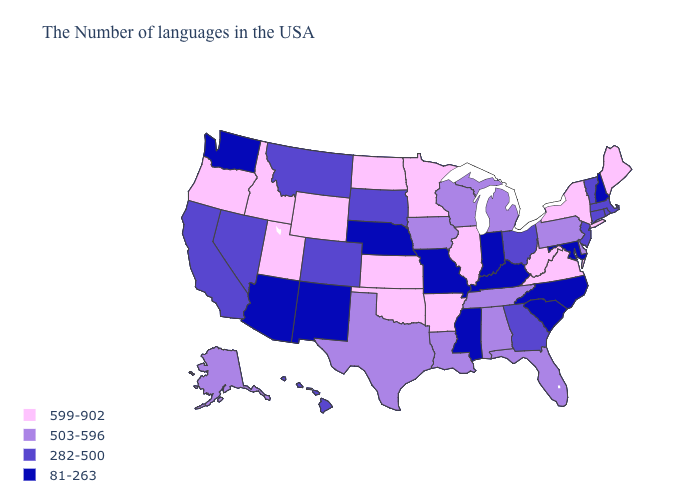Name the states that have a value in the range 503-596?
Give a very brief answer. Delaware, Pennsylvania, Florida, Michigan, Alabama, Tennessee, Wisconsin, Louisiana, Iowa, Texas, Alaska. Does the map have missing data?
Keep it brief. No. Name the states that have a value in the range 503-596?
Keep it brief. Delaware, Pennsylvania, Florida, Michigan, Alabama, Tennessee, Wisconsin, Louisiana, Iowa, Texas, Alaska. Among the states that border Alabama , does Mississippi have the lowest value?
Quick response, please. Yes. What is the value of Montana?
Quick response, please. 282-500. Among the states that border Minnesota , does North Dakota have the highest value?
Keep it brief. Yes. What is the highest value in states that border Vermont?
Concise answer only. 599-902. Which states have the highest value in the USA?
Be succinct. Maine, New York, Virginia, West Virginia, Illinois, Arkansas, Minnesota, Kansas, Oklahoma, North Dakota, Wyoming, Utah, Idaho, Oregon. Among the states that border Delaware , which have the highest value?
Short answer required. Pennsylvania. Name the states that have a value in the range 599-902?
Short answer required. Maine, New York, Virginia, West Virginia, Illinois, Arkansas, Minnesota, Kansas, Oklahoma, North Dakota, Wyoming, Utah, Idaho, Oregon. What is the highest value in the Northeast ?
Short answer required. 599-902. Name the states that have a value in the range 503-596?
Short answer required. Delaware, Pennsylvania, Florida, Michigan, Alabama, Tennessee, Wisconsin, Louisiana, Iowa, Texas, Alaska. Name the states that have a value in the range 503-596?
Short answer required. Delaware, Pennsylvania, Florida, Michigan, Alabama, Tennessee, Wisconsin, Louisiana, Iowa, Texas, Alaska. What is the highest value in states that border Indiana?
Concise answer only. 599-902. What is the highest value in the USA?
Write a very short answer. 599-902. 